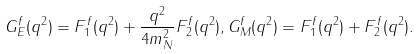Convert formula to latex. <formula><loc_0><loc_0><loc_500><loc_500>G _ { E } ^ { f } ( q ^ { 2 } ) = F _ { 1 } ^ { f } ( q ^ { 2 } ) + \frac { q ^ { 2 } } { 4 m _ { N } ^ { 2 } } F _ { 2 } ^ { f } ( q ^ { 2 } ) , G _ { M } ^ { f } ( q ^ { 2 } ) = F _ { 1 } ^ { f } ( q ^ { 2 } ) + F _ { 2 } ^ { f } ( q ^ { 2 } ) .</formula> 